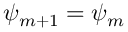<formula> <loc_0><loc_0><loc_500><loc_500>\psi _ { m + 1 } = \psi _ { m }</formula> 